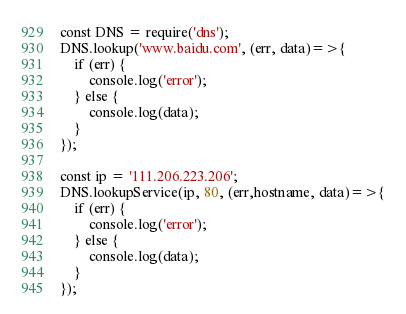Convert code to text. <code><loc_0><loc_0><loc_500><loc_500><_JavaScript_>const DNS = require('dns');
DNS.lookup('www.baidu.com', (err, data)=>{
    if (err) {
        console.log('error');
    } else {
        console.log(data);
    }
});

const ip = '111.206.223.206';
DNS.lookupService(ip, 80, (err,hostname, data)=>{
    if (err) {
        console.log('error');
    } else {
        console.log(data);
    }
});</code> 